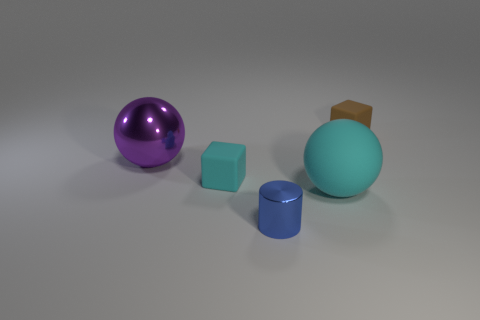Add 3 tiny gray rubber cylinders. How many objects exist? 8 Subtract all spheres. How many objects are left? 3 Add 1 tiny brown blocks. How many tiny brown blocks are left? 2 Add 3 blue metallic cylinders. How many blue metallic cylinders exist? 4 Subtract 0 yellow balls. How many objects are left? 5 Subtract all blue metallic cylinders. Subtract all small brown rubber objects. How many objects are left? 3 